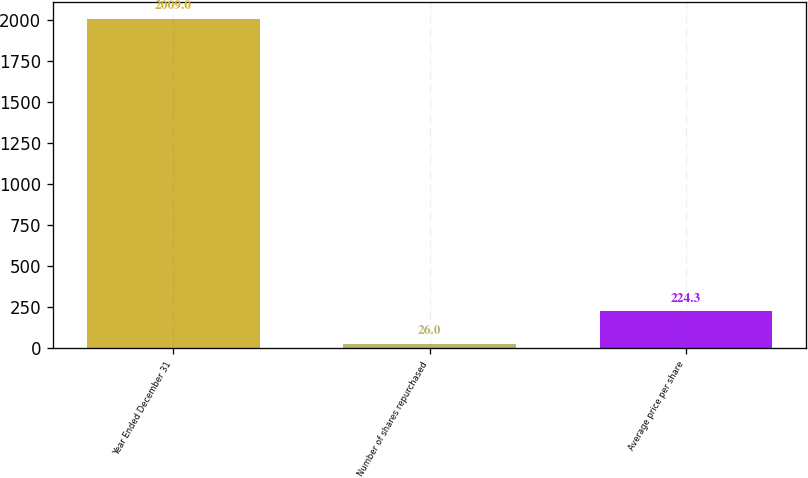<chart> <loc_0><loc_0><loc_500><loc_500><bar_chart><fcel>Year Ended December 31<fcel>Number of shares repurchased<fcel>Average price per share<nl><fcel>2009<fcel>26<fcel>224.3<nl></chart> 